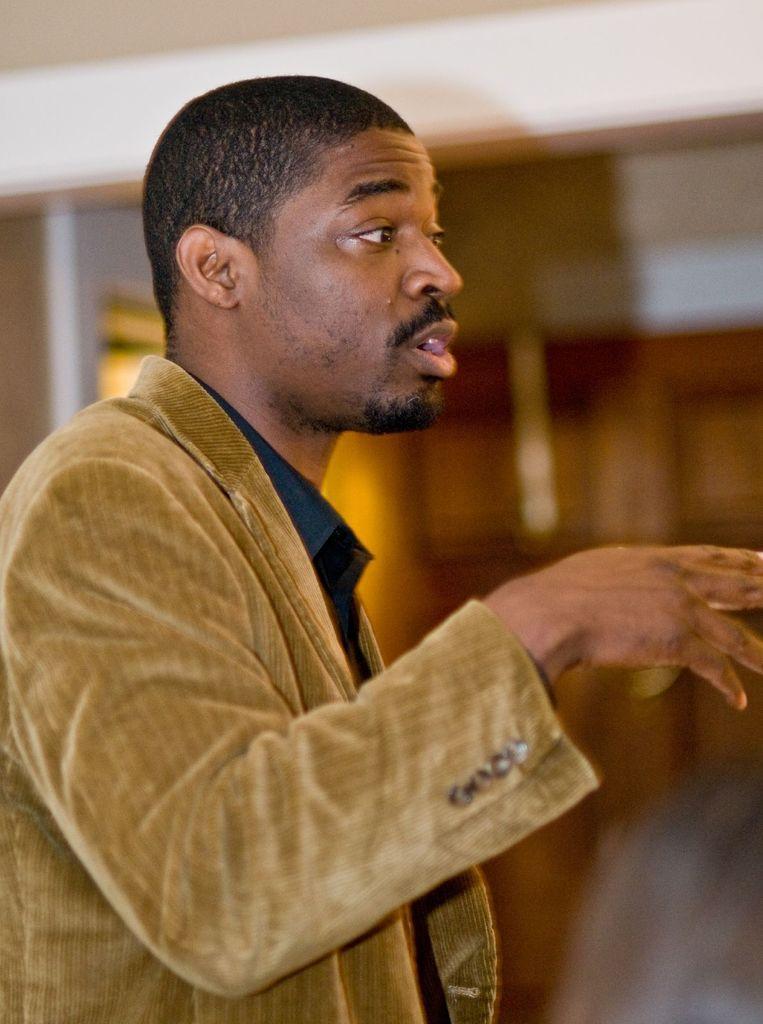Can you describe this image briefly? In the image I can see a person who is wearing the jacket. 